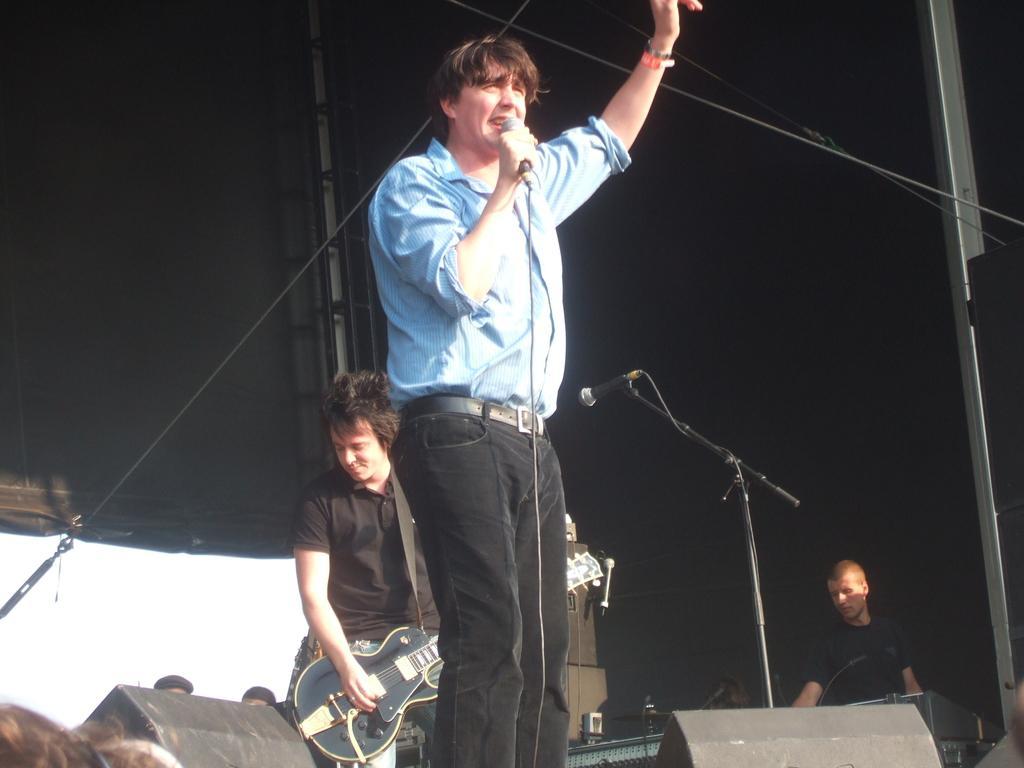Describe this image in one or two sentences. In the image there is a man standing and holding a microphone for singing, in background there is a black color shirt man playing a guitar and we can also see a microphone and a person in background. 